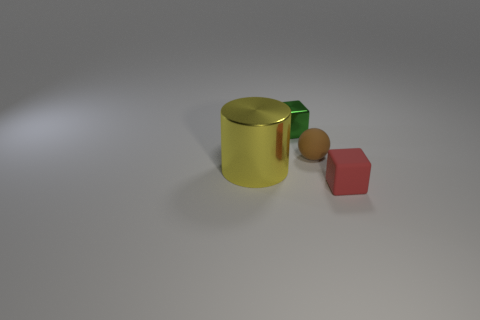Add 3 tiny green metal things. How many objects exist? 7 Subtract all cylinders. How many objects are left? 3 Subtract all small yellow metal objects. Subtract all large shiny cylinders. How many objects are left? 3 Add 3 tiny green shiny objects. How many tiny green shiny objects are left? 4 Add 3 tiny purple metallic blocks. How many tiny purple metallic blocks exist? 3 Subtract 0 purple balls. How many objects are left? 4 